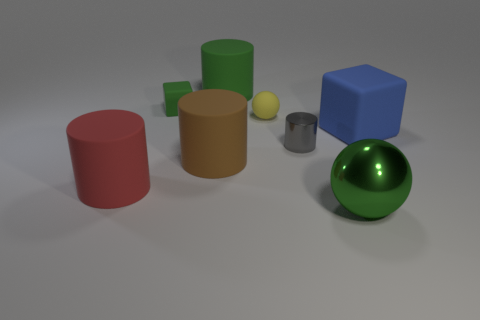Add 1 tiny yellow matte things. How many objects exist? 9 Subtract all cubes. How many objects are left? 6 Add 2 blue blocks. How many blue blocks exist? 3 Subtract 0 gray balls. How many objects are left? 8 Subtract all purple objects. Subtract all large blue matte blocks. How many objects are left? 7 Add 6 small green things. How many small green things are left? 7 